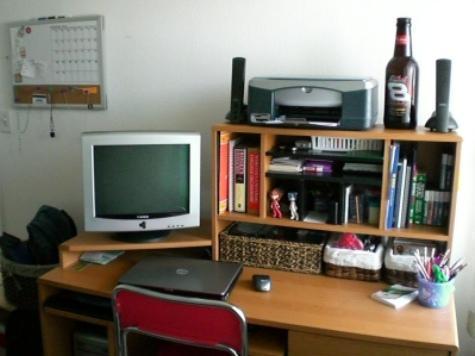How many printers are pictured?
Give a very brief answer. 1. How many computer speakers are pictured?
Give a very brief answer. 2. 